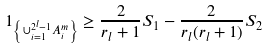<formula> <loc_0><loc_0><loc_500><loc_500>1 _ { \left \{ \cup _ { i = 1 } ^ { 2 ^ { l } - 1 } A _ { i } ^ { m } \right \} } \geq \frac { 2 } { r _ { l } + 1 } S _ { 1 } - \frac { 2 } { r _ { l } ( r _ { l } + 1 ) } S _ { 2 }</formula> 